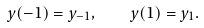Convert formula to latex. <formula><loc_0><loc_0><loc_500><loc_500>y ( - 1 ) = y _ { - 1 } , \quad y ( 1 ) = y _ { 1 } .</formula> 